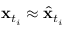Convert formula to latex. <formula><loc_0><loc_0><loc_500><loc_500>x _ { t _ { i } } \approx \hat { x } _ { t _ { i } }</formula> 